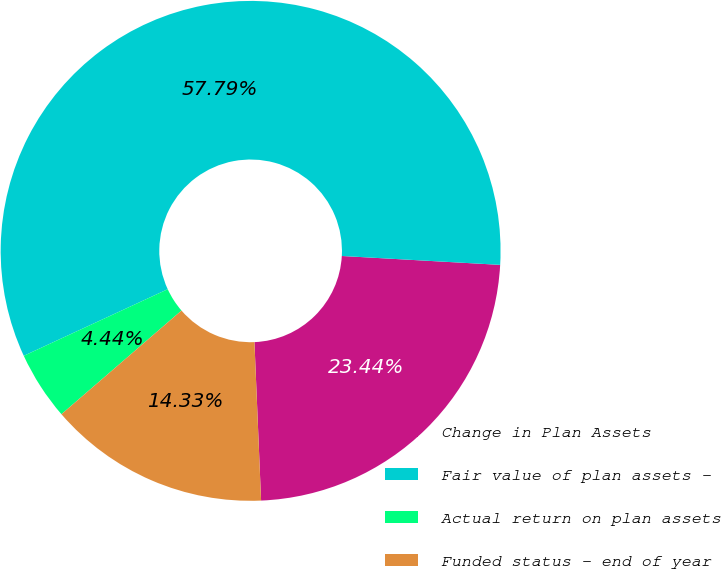<chart> <loc_0><loc_0><loc_500><loc_500><pie_chart><fcel>Change in Plan Assets<fcel>Fair value of plan assets -<fcel>Actual return on plan assets<fcel>Funded status - end of year<nl><fcel>23.44%<fcel>57.79%<fcel>4.44%<fcel>14.33%<nl></chart> 